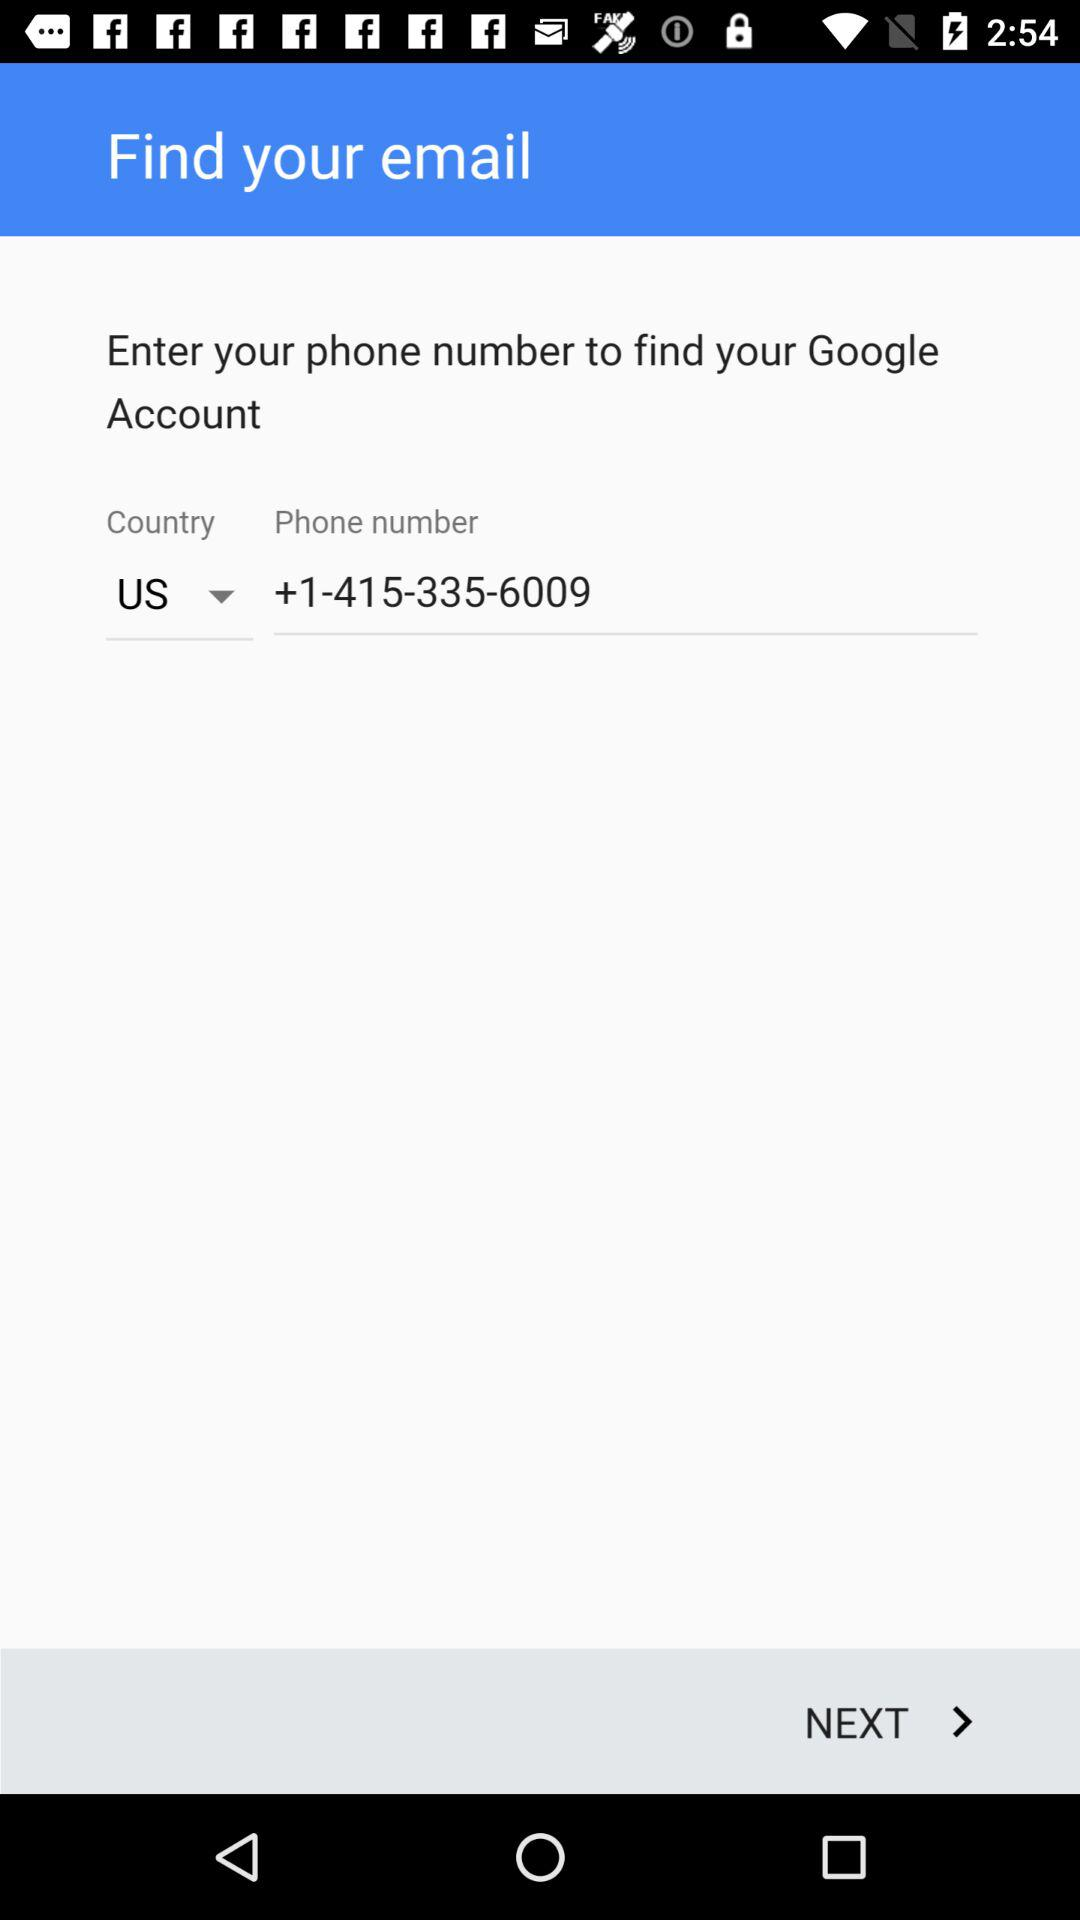What is the selected country? The selected country is the US. 